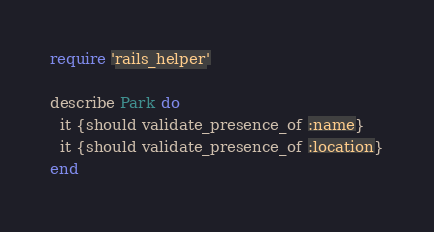Convert code to text. <code><loc_0><loc_0><loc_500><loc_500><_Ruby_>require 'rails_helper'

describe Park do
  it {should validate_presence_of :name}
  it {should validate_presence_of :location}
end</code> 